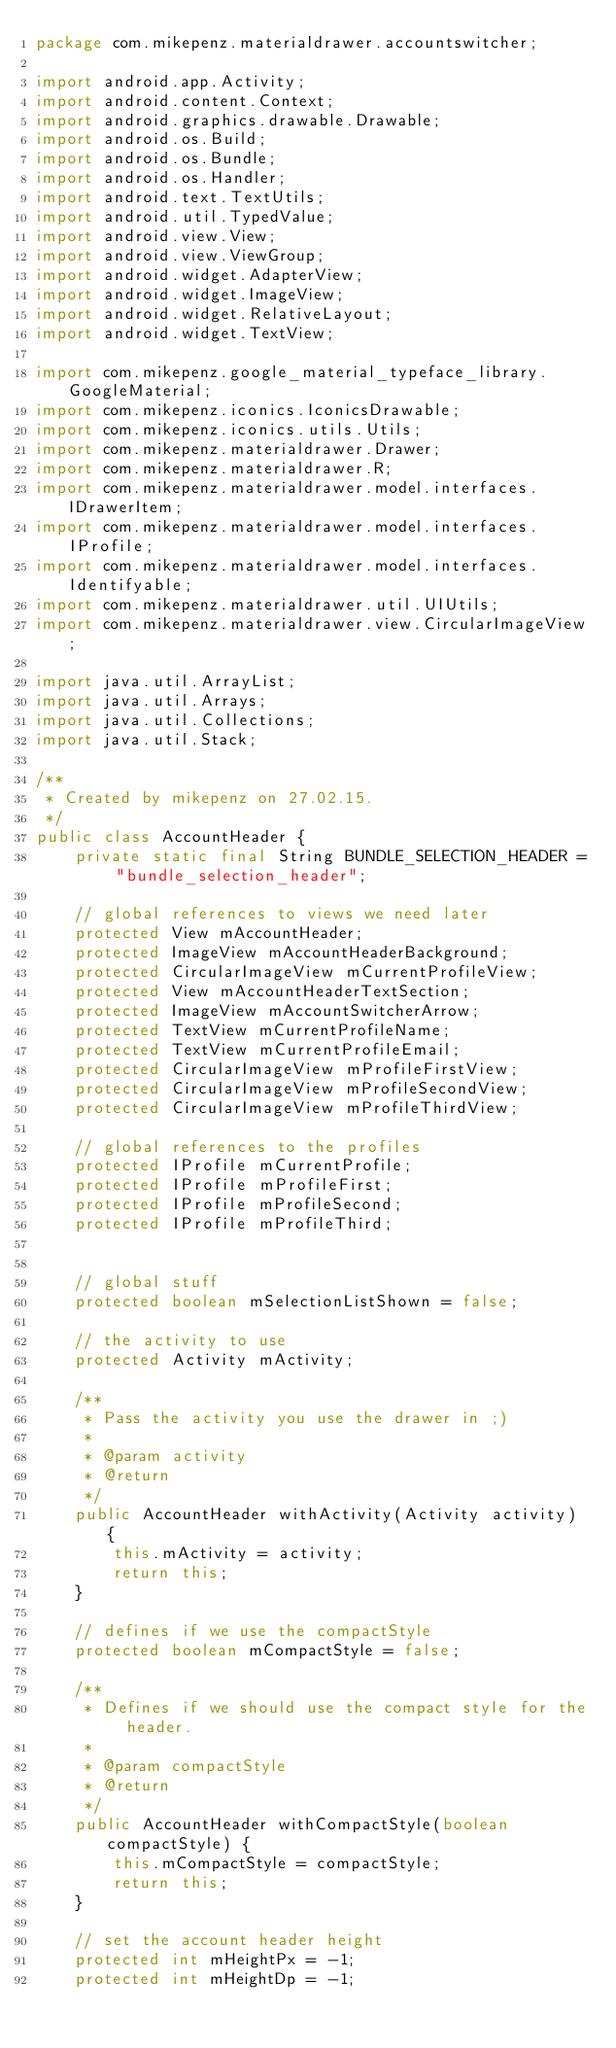Convert code to text. <code><loc_0><loc_0><loc_500><loc_500><_Java_>package com.mikepenz.materialdrawer.accountswitcher;

import android.app.Activity;
import android.content.Context;
import android.graphics.drawable.Drawable;
import android.os.Build;
import android.os.Bundle;
import android.os.Handler;
import android.text.TextUtils;
import android.util.TypedValue;
import android.view.View;
import android.view.ViewGroup;
import android.widget.AdapterView;
import android.widget.ImageView;
import android.widget.RelativeLayout;
import android.widget.TextView;

import com.mikepenz.google_material_typeface_library.GoogleMaterial;
import com.mikepenz.iconics.IconicsDrawable;
import com.mikepenz.iconics.utils.Utils;
import com.mikepenz.materialdrawer.Drawer;
import com.mikepenz.materialdrawer.R;
import com.mikepenz.materialdrawer.model.interfaces.IDrawerItem;
import com.mikepenz.materialdrawer.model.interfaces.IProfile;
import com.mikepenz.materialdrawer.model.interfaces.Identifyable;
import com.mikepenz.materialdrawer.util.UIUtils;
import com.mikepenz.materialdrawer.view.CircularImageView;

import java.util.ArrayList;
import java.util.Arrays;
import java.util.Collections;
import java.util.Stack;

/**
 * Created by mikepenz on 27.02.15.
 */
public class AccountHeader {
    private static final String BUNDLE_SELECTION_HEADER = "bundle_selection_header";

    // global references to views we need later
    protected View mAccountHeader;
    protected ImageView mAccountHeaderBackground;
    protected CircularImageView mCurrentProfileView;
    protected View mAccountHeaderTextSection;
    protected ImageView mAccountSwitcherArrow;
    protected TextView mCurrentProfileName;
    protected TextView mCurrentProfileEmail;
    protected CircularImageView mProfileFirstView;
    protected CircularImageView mProfileSecondView;
    protected CircularImageView mProfileThirdView;

    // global references to the profiles
    protected IProfile mCurrentProfile;
    protected IProfile mProfileFirst;
    protected IProfile mProfileSecond;
    protected IProfile mProfileThird;


    // global stuff
    protected boolean mSelectionListShown = false;

    // the activity to use
    protected Activity mActivity;

    /**
     * Pass the activity you use the drawer in ;)
     *
     * @param activity
     * @return
     */
    public AccountHeader withActivity(Activity activity) {
        this.mActivity = activity;
        return this;
    }

    // defines if we use the compactStyle
    protected boolean mCompactStyle = false;

    /**
     * Defines if we should use the compact style for the header.
     *
     * @param compactStyle
     * @return
     */
    public AccountHeader withCompactStyle(boolean compactStyle) {
        this.mCompactStyle = compactStyle;
        return this;
    }

    // set the account header height
    protected int mHeightPx = -1;
    protected int mHeightDp = -1;</code> 